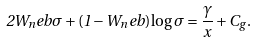<formula> <loc_0><loc_0><loc_500><loc_500>2 W _ { n } e b \sigma + ( 1 - W _ { n } e b ) \log \sigma = \frac { \gamma } { x } + C _ { g } .</formula> 